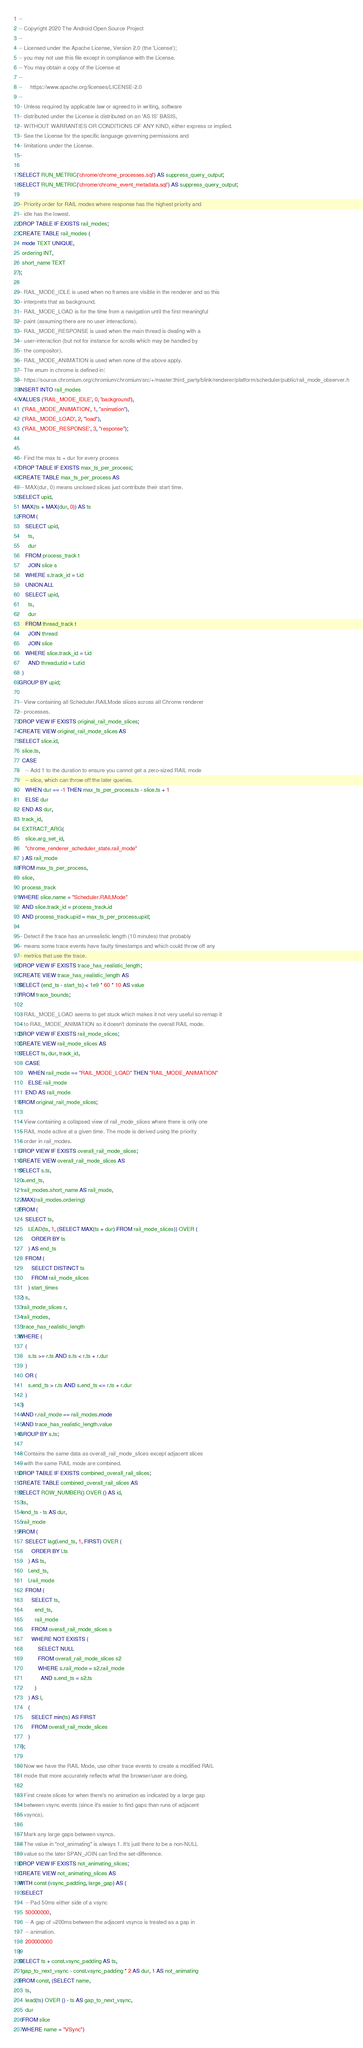Convert code to text. <code><loc_0><loc_0><loc_500><loc_500><_SQL_>--
-- Copyright 2020 The Android Open Source Project
--
-- Licensed under the Apache License, Version 2.0 (the 'License');
-- you may not use this file except in compliance with the License.
-- You may obtain a copy of the License at
--
--     https://www.apache.org/licenses/LICENSE-2.0
--
-- Unless required by applicable law or agreed to in writing, software
-- distributed under the License is distributed on an 'AS IS' BASIS,
-- WITHOUT WARRANTIES OR CONDITIONS OF ANY KIND, either express or implied.
-- See the License for the specific language governing permissions and
-- limitations under the License.
--

SELECT RUN_METRIC('chrome/chrome_processes.sql') AS suppress_query_output;
SELECT RUN_METRIC('chrome/chrome_event_metadata.sql') AS suppress_query_output;

-- Priority order for RAIL modes where response has the highest priority and
-- idle has the lowest.
DROP TABLE IF EXISTS rail_modes;
CREATE TABLE rail_modes (
  mode TEXT UNIQUE,
  ordering INT,
  short_name TEXT
);

-- RAIL_MODE_IDLE is used when no frames are visible in the renderer and so this
-- interprets that as background.
-- RAIL_MODE_LOAD is for the time from a navigation until the first meaningful
-- paint (assuming there are no user interactions).
-- RAIL_MODE_RESPONSE is used when the main thread is dealing with a
-- user-interaction (but not for instance for scrolls which may be handled by
-- the compositor).
-- RAIL_MODE_ANIMATION is used when none of the above apply.
-- The enum in chrome is defined in:
-- https://source.chromium.org/chromium/chromium/src/+/master:third_party/blink/renderer/platform/scheduler/public/rail_mode_observer.h
INSERT INTO rail_modes
VALUES ('RAIL_MODE_IDLE', 0, 'background'),
  ('RAIL_MODE_ANIMATION', 1, "animation"),
  ('RAIL_MODE_LOAD', 2, "load"),
  ('RAIL_MODE_RESPONSE', 3, "response");


-- Find the max ts + dur for every process
DROP TABLE IF EXISTS max_ts_per_process;
CREATE TABLE max_ts_per_process AS
 -- MAX(dur, 0) means unclosed slices just contribute their start time.
SELECT upid,
  MAX(ts + MAX(dur, 0)) AS ts
FROM (
    SELECT upid,
      ts,
      dur
    FROM process_track t
      JOIN slice s
    WHERE s.track_id = t.id
    UNION ALL
    SELECT upid,
      ts,
      dur
    FROM thread_track t
      JOIN thread
      JOIN slice
    WHERE slice.track_id = t.id
      AND thread.utid = t.utid
  )
GROUP BY upid;

-- View containing all Scheduler.RAILMode slices across all Chrome renderer
-- processes.
DROP VIEW IF EXISTS original_rail_mode_slices;
CREATE VIEW original_rail_mode_slices AS
SELECT slice.id,
  slice.ts,
  CASE
    -- Add 1 to the duration to ensure you cannot get a zero-sized RAIL mode
    -- slice, which can throw off the later queries.
    WHEN dur == -1 THEN max_ts_per_process.ts - slice.ts + 1
    ELSE dur
  END AS dur,
  track_id,
  EXTRACT_ARG(
    slice.arg_set_id,
    "chrome_renderer_scheduler_state.rail_mode"
  ) AS rail_mode
FROM max_ts_per_process,
  slice,
  process_track
WHERE slice.name = "Scheduler.RAILMode"
  AND slice.track_id = process_track.id
  AND process_track.upid = max_ts_per_process.upid;

-- Detect if the trace has an unrealistic length (10 minutes) that probably
-- means some trace events have faulty timestamps and which could throw off any
-- metrics that use the trace.
DROP VIEW IF EXISTS trace_has_realistic_length;
CREATE VIEW trace_has_realistic_length AS
SELECT (end_ts - start_ts) < 1e9 * 60 * 10 AS value
FROM trace_bounds;

-- RAIL_MODE_LOAD seems to get stuck which makes it not very useful so remap it
-- to RAIL_MODE_ANIMATION so it doesn't dominate the overall RAIL mode.
DROP VIEW IF EXISTS rail_mode_slices;
CREATE VIEW rail_mode_slices AS
SELECT ts, dur, track_id,
    CASE
      WHEN rail_mode == "RAIL_MODE_LOAD" THEN "RAIL_MODE_ANIMATION"
      ELSE rail_mode
    END AS rail_mode
FROM original_rail_mode_slices;

-- View containing a collapsed view of rail_mode_slices where there is only one
-- RAIL mode active at a given time. The mode is derived using the priority
-- order in rail_modes.
DROP VIEW IF EXISTS overall_rail_mode_slices;
CREATE VIEW overall_rail_mode_slices AS
SELECT s.ts,
  s.end_ts,
  rail_modes.short_name AS rail_mode,
  MAX(rail_modes.ordering)
FROM (
    SELECT ts,
      LEAD(ts, 1, (SELECT MAX(ts + dur) FROM rail_mode_slices)) OVER (
        ORDER BY ts
      ) AS end_ts
    FROM (
        SELECT DISTINCT ts
        FROM rail_mode_slices
      ) start_times
  ) s,
  rail_mode_slices r,
  rail_modes,
  trace_has_realistic_length
WHERE (
    (
      s.ts >= r.ts AND s.ts < r.ts + r.dur
    )
    OR (
      s.end_ts > r.ts AND s.end_ts <= r.ts + r.dur
    )
  )
  AND r.rail_mode == rail_modes.mode
  AND trace_has_realistic_length.value
GROUP BY s.ts;

-- Contains the same data as overall_rail_mode_slices except adjacent slices
-- with the same RAIL mode are combined.
DROP TABLE IF EXISTS combined_overall_rail_slices;
CREATE TABLE combined_overall_rail_slices AS
SELECT ROW_NUMBER() OVER () AS id,
  ts,
  end_ts - ts AS dur,
  rail_mode
FROM (
    SELECT lag(l.end_ts, 1, FIRST) OVER (
        ORDER BY l.ts
      ) AS ts,
      l.end_ts,
      l.rail_mode
    FROM (
        SELECT ts,
          end_ts,
          rail_mode
        FROM overall_rail_mode_slices s
        WHERE NOT EXISTS (
            SELECT NULL
            FROM overall_rail_mode_slices s2
            WHERE s.rail_mode = s2.rail_mode
              AND s.end_ts = s2.ts
          )
      ) AS l,
      (
        SELECT min(ts) AS FIRST
        FROM overall_rail_mode_slices
      )
  );

-- Now we have the RAIL Mode, use other trace events to create a modified RAIL
-- mode that more accurately reflects what the browser/user are doing.

-- First create slices for when there's no animation as indicated by a large gap
-- between vsync events (since it's easier to find gaps than runs of adjacent
-- vsyncs).

-- Mark any large gaps between vsyncs.
-- The value in "not_animating" is always 1. It's just there to be a non-NULL
-- value so the later SPAN_JOIN can find the set-difference.
DROP VIEW IF EXISTS not_animating_slices;
CREATE VIEW not_animating_slices AS
WITH const (vsync_padding, large_gap) AS (
  SELECT
    -- Pad 50ms either side of a vsync
    50000000,
    -- A gap of >200ms between the adjacent vsyncs is treated as a gap in
    -- animation.
    200000000
)
SELECT ts + const.vsync_padding AS ts,
  gap_to_next_vsync - const.vsync_padding * 2 AS dur, 1 AS not_animating
FROM const, (SELECT name,
    ts,
    lead(ts) OVER () - ts AS gap_to_next_vsync,
    dur
  FROM slice
  WHERE name = "VSync")</code> 